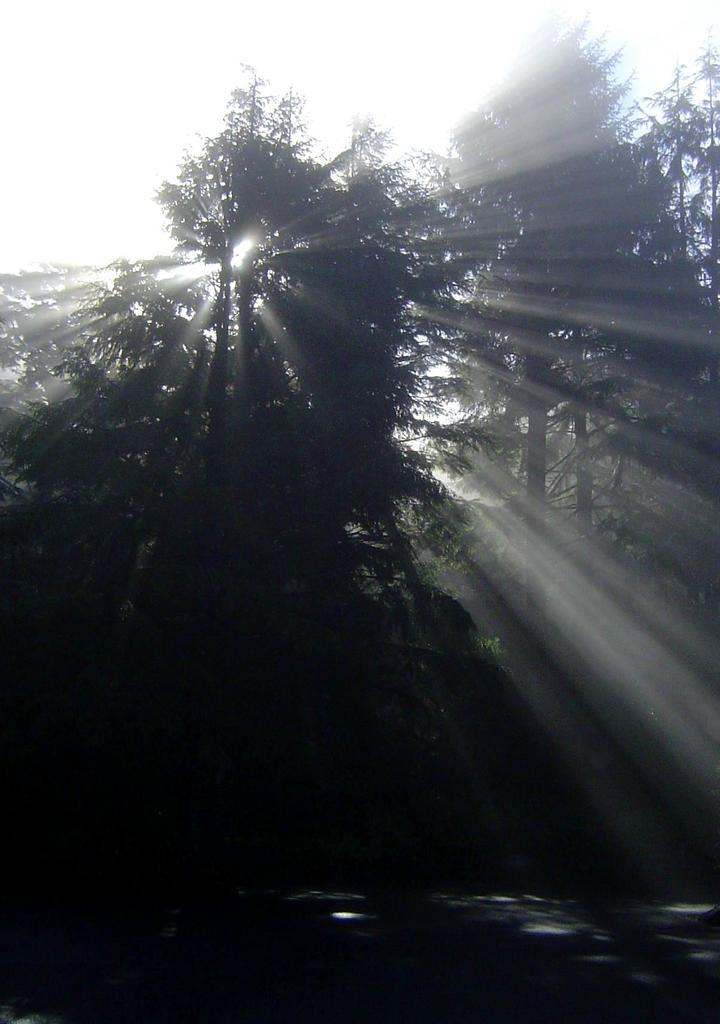What type of vegetation can be seen in the background of the image? There are trees in the background of the image. What else is visible in the background of the image? The sky is visible in the background of the image. How many cherries are hanging from the neck of the person in the image? There is no person present in the image, and therefore no neck or cherries to count. What type of floor is visible in the image? There is no floor visible in the image; it only shows trees and the sky in the background. 